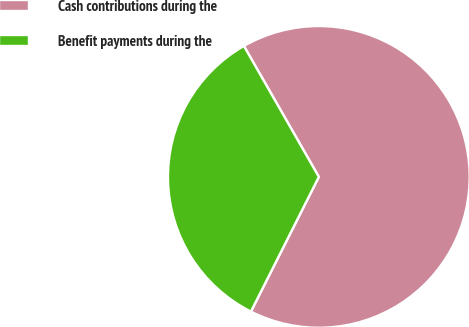Convert chart to OTSL. <chart><loc_0><loc_0><loc_500><loc_500><pie_chart><fcel>Cash contributions during the<fcel>Benefit payments during the<nl><fcel>65.71%<fcel>34.29%<nl></chart> 